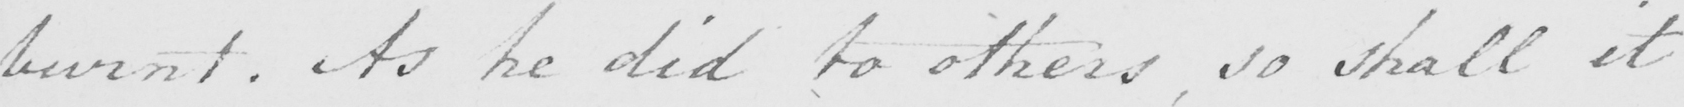Can you read and transcribe this handwriting? burnt . As he did to others , so shall it 